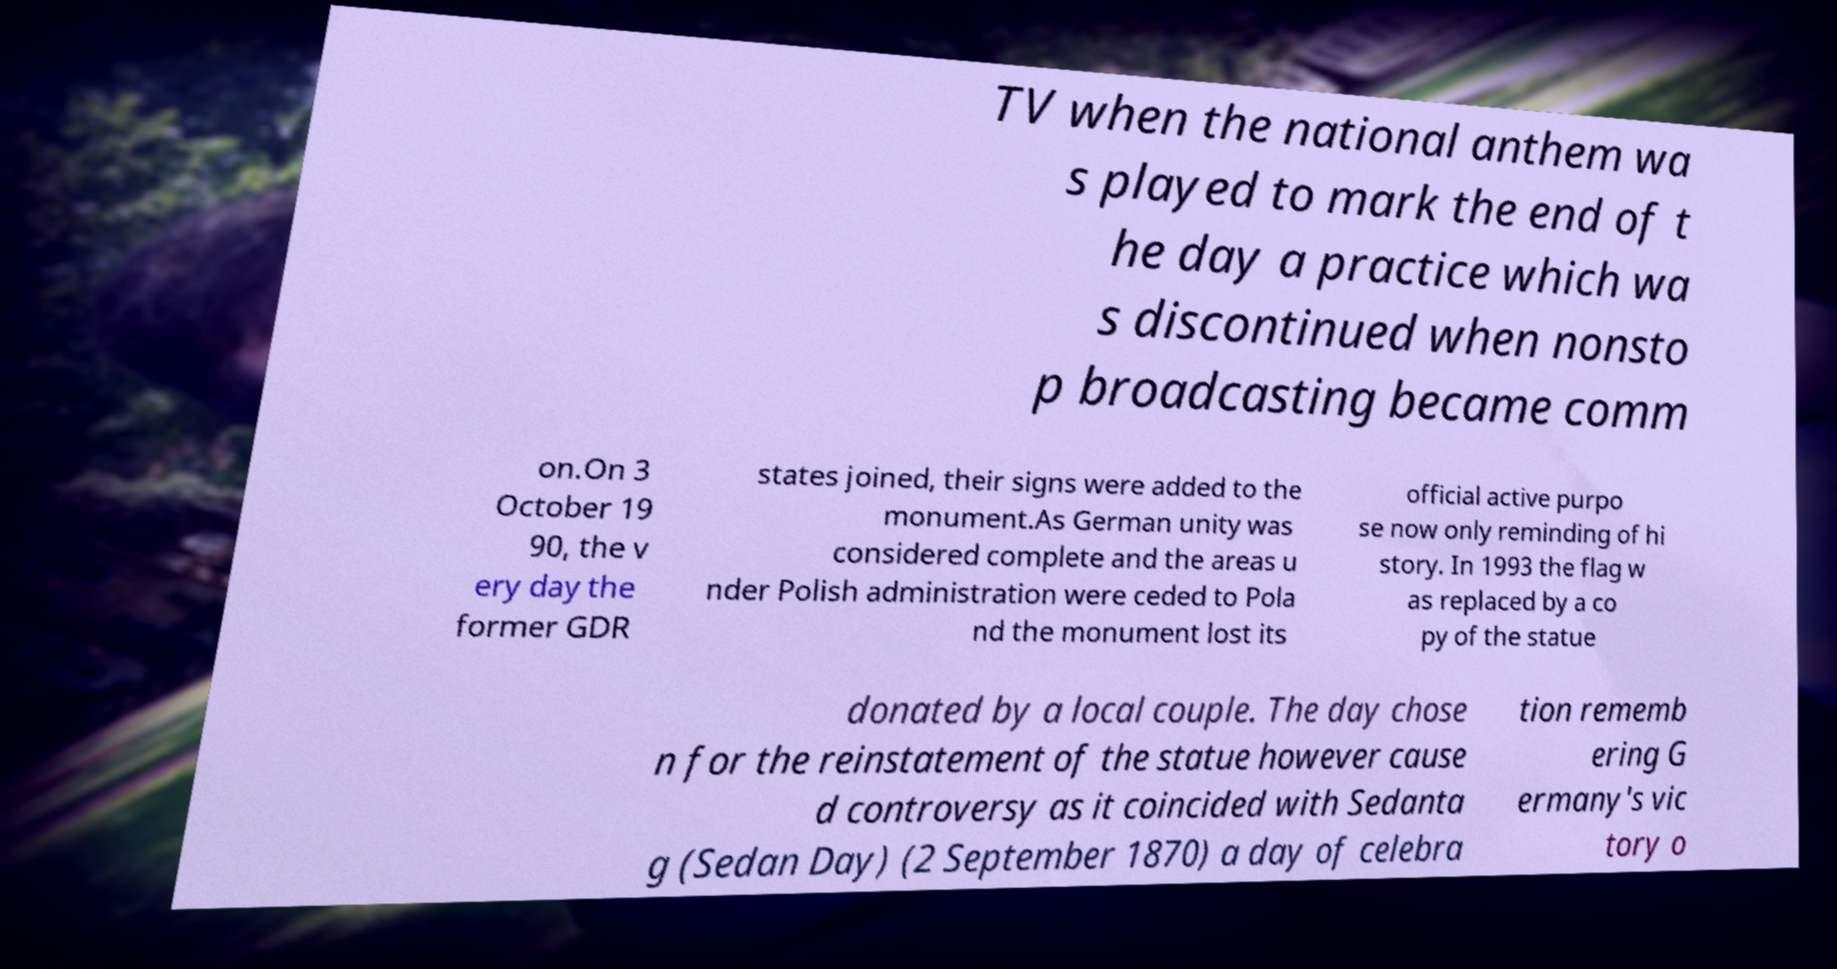Can you accurately transcribe the text from the provided image for me? TV when the national anthem wa s played to mark the end of t he day a practice which wa s discontinued when nonsto p broadcasting became comm on.On 3 October 19 90, the v ery day the former GDR states joined, their signs were added to the monument.As German unity was considered complete and the areas u nder Polish administration were ceded to Pola nd the monument lost its official active purpo se now only reminding of hi story. In 1993 the flag w as replaced by a co py of the statue donated by a local couple. The day chose n for the reinstatement of the statue however cause d controversy as it coincided with Sedanta g (Sedan Day) (2 September 1870) a day of celebra tion rememb ering G ermany's vic tory o 